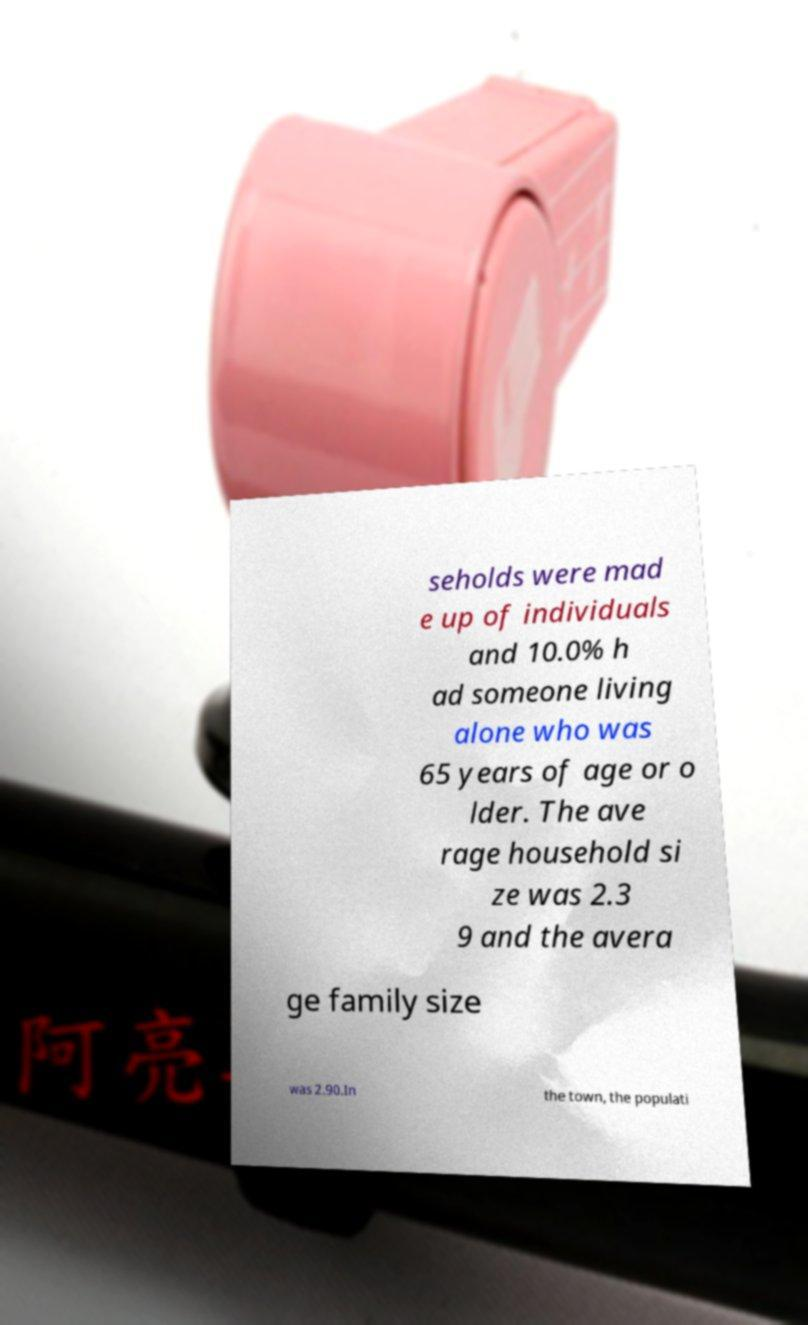I need the written content from this picture converted into text. Can you do that? seholds were mad e up of individuals and 10.0% h ad someone living alone who was 65 years of age or o lder. The ave rage household si ze was 2.3 9 and the avera ge family size was 2.90.In the town, the populati 